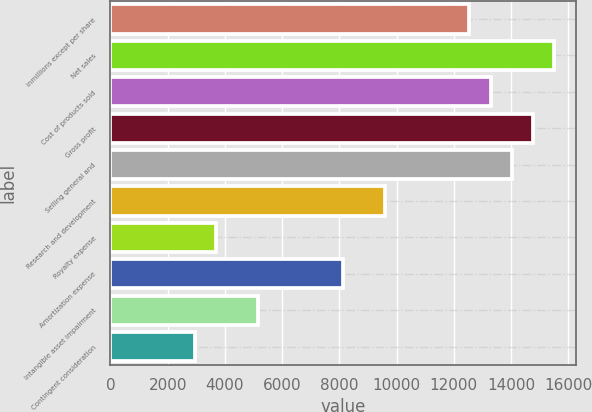Convert chart to OTSL. <chart><loc_0><loc_0><loc_500><loc_500><bar_chart><fcel>inmillions except per share<fcel>Net sales<fcel>Cost of products sold<fcel>Gross profit<fcel>Selling general and<fcel>Research and development<fcel>Royalty expense<fcel>Amortization expense<fcel>Intangible asset impairment<fcel>Contingent consideration<nl><fcel>12545.9<fcel>15497.9<fcel>13283.9<fcel>14759.9<fcel>14021.9<fcel>9593.96<fcel>3690.04<fcel>8117.98<fcel>5166.02<fcel>2952.05<nl></chart> 